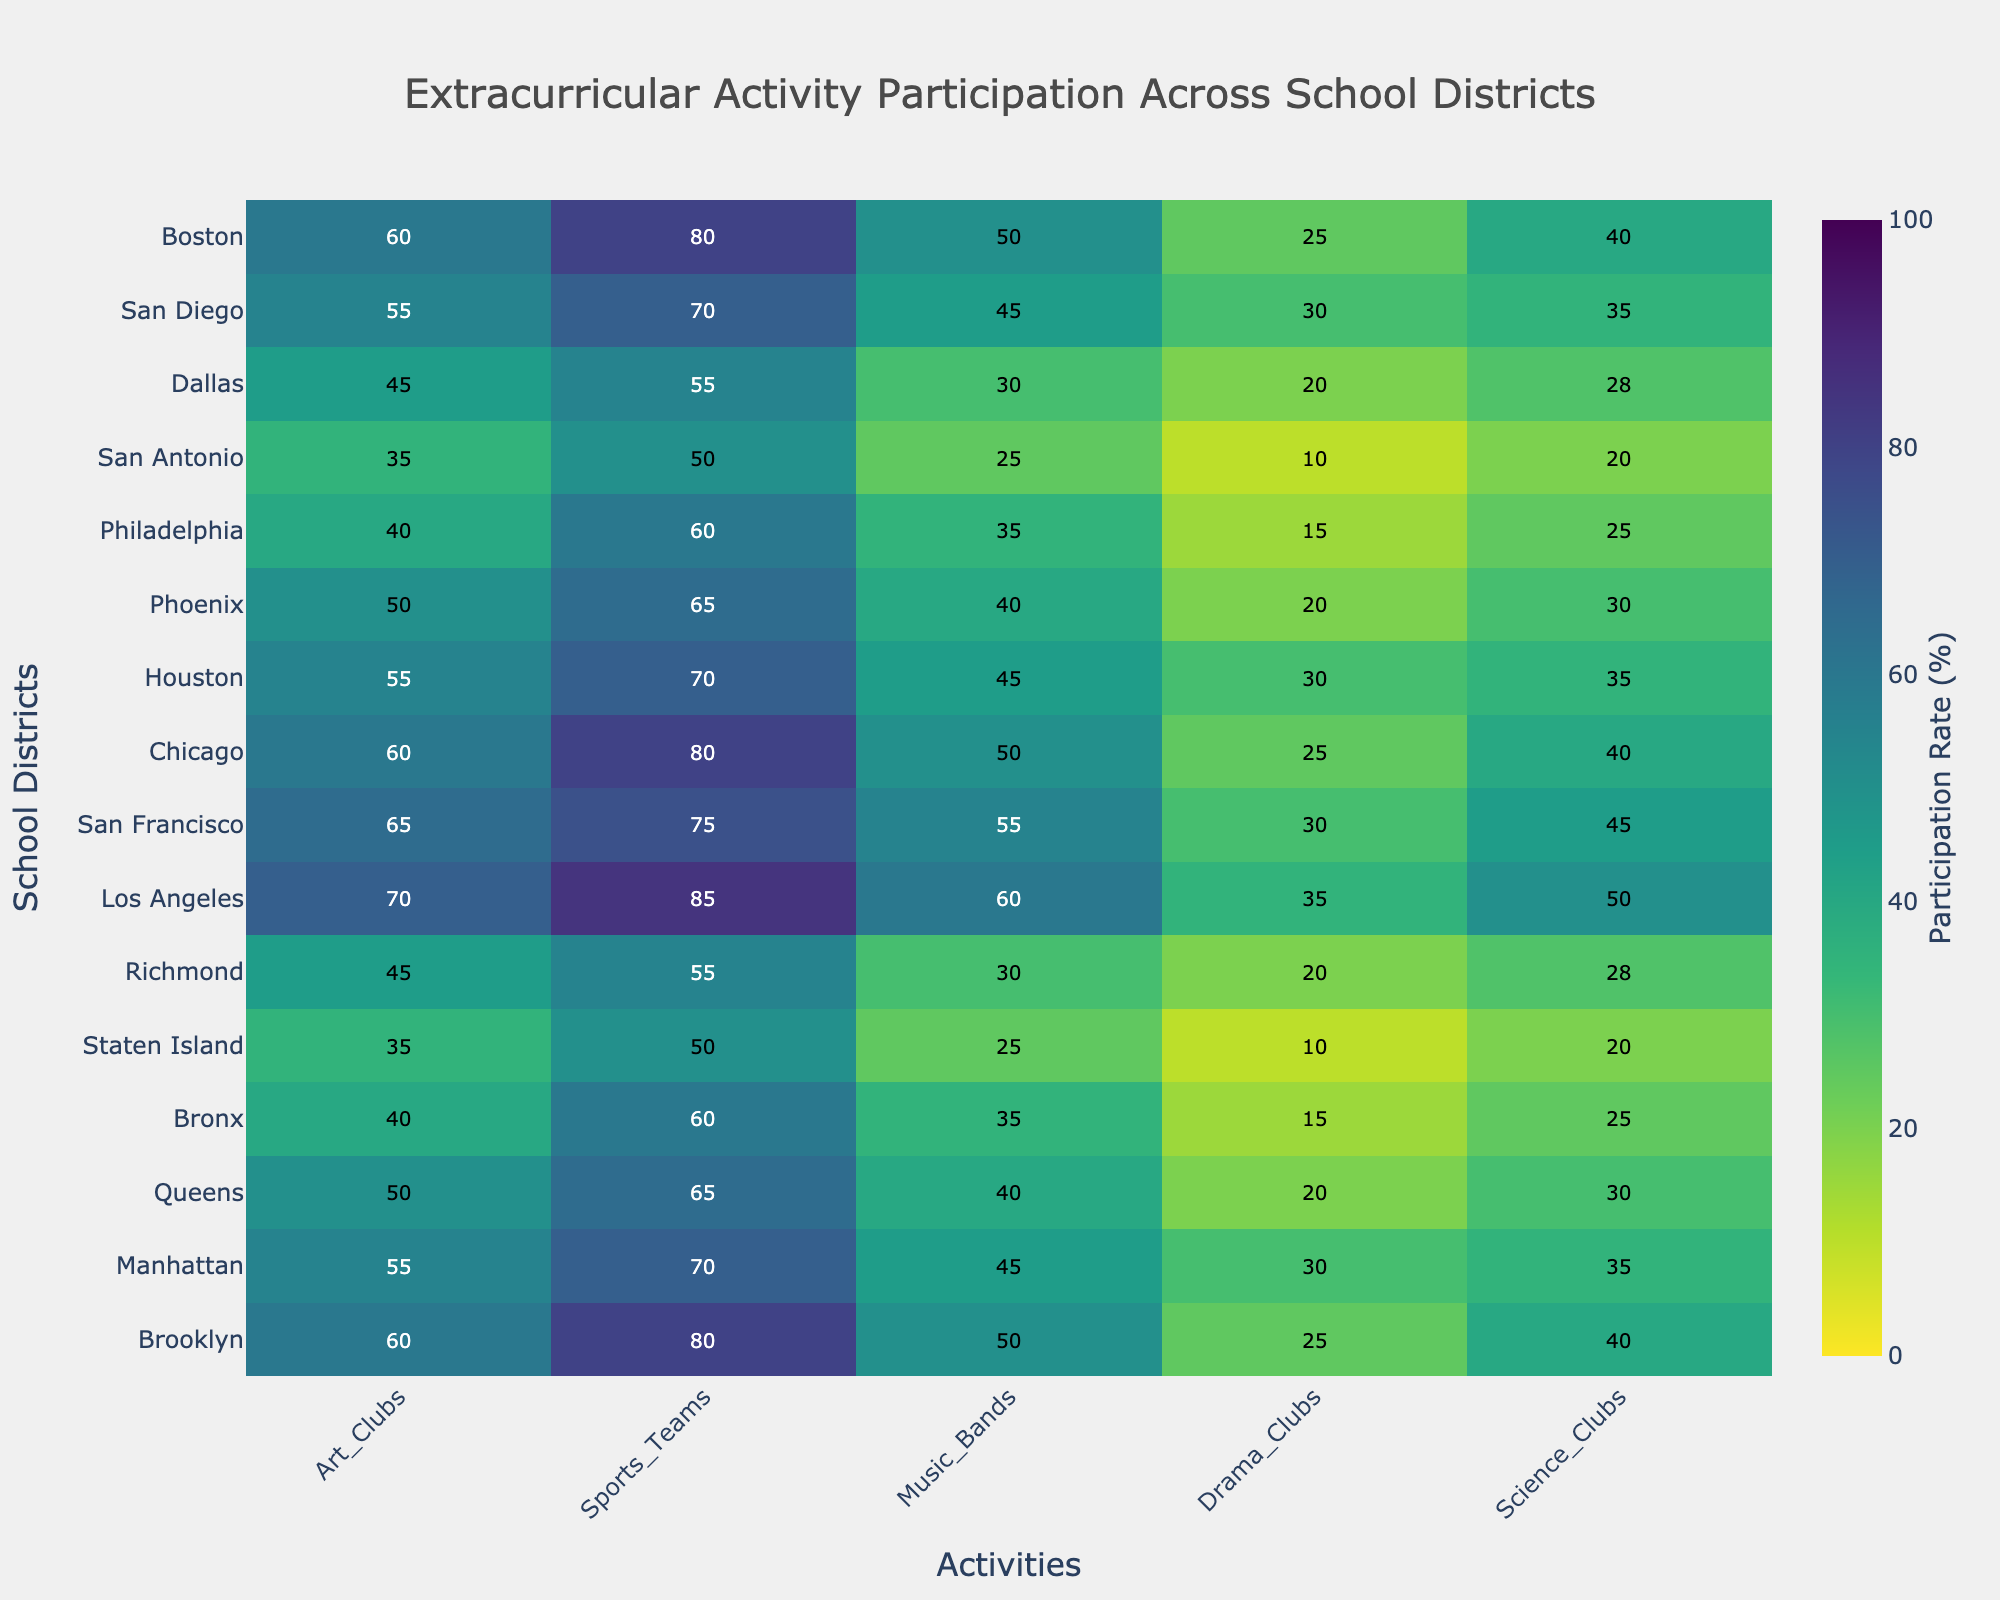What is the title of the heatmap? The title of the heatmap is located at the top center of the figure. It reads, "Extracurricular Activity Participation Across School Districts."
Answer: Extracurricular Activity Participation Across School Districts Which school district has the highest participation rate in Sports Teams? To find the district with the highest participation in Sports Teams, look at the 'Sports_Teams' column and identify the highest value. Los Angeles has the highest value of 85%.
Answer: Los Angeles How many districts have a participation rate in Art Clubs greater than 55%? Count the number of values greater than 55% in the 'Art_Clubs' column. There are five such districts: Brooklyn, Los Angeles, San Francisco, Chicago, and Boston.
Answer: Five What is the average participation rate in Drama Clubs across all districts? Sum the values in the 'Drama_Clubs' column and divide by the number of districts (16). (25+30+20+15+10+20+35+30+25+30+20+15+10+20+30+25) / 16 = 380 / 16 = 23.75%
Answer: 23.75% Which district has the lowest participation rate in Science Clubs and what is the rate? Find the minimum value in the 'Science_Clubs' column and identify the corresponding district. Staten Island has the lowest rate of 20%.
Answer: Staten Island, 20% What is the participation difference between Queens and Manhattan in Music Bands? Subtract the participation rate of Queens (40%) from Manhattan (45%). 45% - 40% = 5% difference.
Answer: 5% Across all districts, which activity has the highest average participation rate? Calculate the average for each activity and compare. Sports Teams has the highest average: (80+70+65+60+50+55+85+75+80+70+65+60+50+55+70+80) / 16 = 1120 / 16 = 70%.
Answer: Sports Teams Compare the participation rates in Art Clubs between Brooklyn and Richmond. Which one is higher and by how much? The participation rate in Art Clubs for Brooklyn is 60% and for Richmond is 45%. Subtract Richmond's rate from Brooklyn's. 60% - 45% = 15%. Brooklyn's rate is higher by 15%.
Answer: Brooklyn, 15% What is the range of participation rates for Music Bands across the districts? To get the range, subtract the minimum participation rate from the maximum in the 'Music_Bands' column. The values range from 25% to 60%, so 60% - 25% = 35%.
Answer: 35% Identify the districts with a participation rate of 50% in Music Bands. Look at the 'Music_Bands' column to find all values of 50%. Brooklyn, Chicago, and Boston each have a participation rate of 50% in Music Bands.
Answer: Brooklyn, Chicago, Boston 